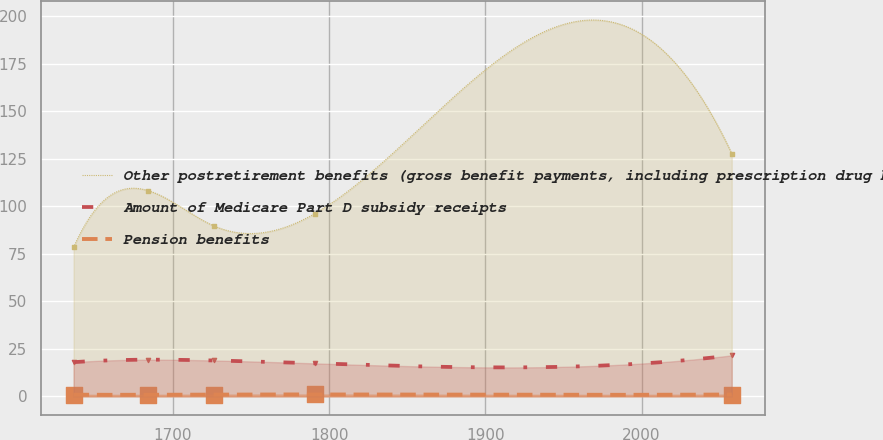Convert chart to OTSL. <chart><loc_0><loc_0><loc_500><loc_500><line_chart><ecel><fcel>Other postretirement benefits (gross benefit payments, including prescription drug benefits)<fcel>Amount of Medicare Part D subsidy receipts<fcel>Pension benefits<nl><fcel>1636.33<fcel>78.45<fcel>18.01<fcel>0.89<nl><fcel>1684.13<fcel>108.29<fcel>19.32<fcel>0.84<nl><fcel>1726.27<fcel>89.7<fcel>18.9<fcel>0.95<nl><fcel>1790.78<fcel>96.21<fcel>17.37<fcel>1.01<nl><fcel>2057.74<fcel>127.75<fcel>21.6<fcel>0.98<nl></chart> 